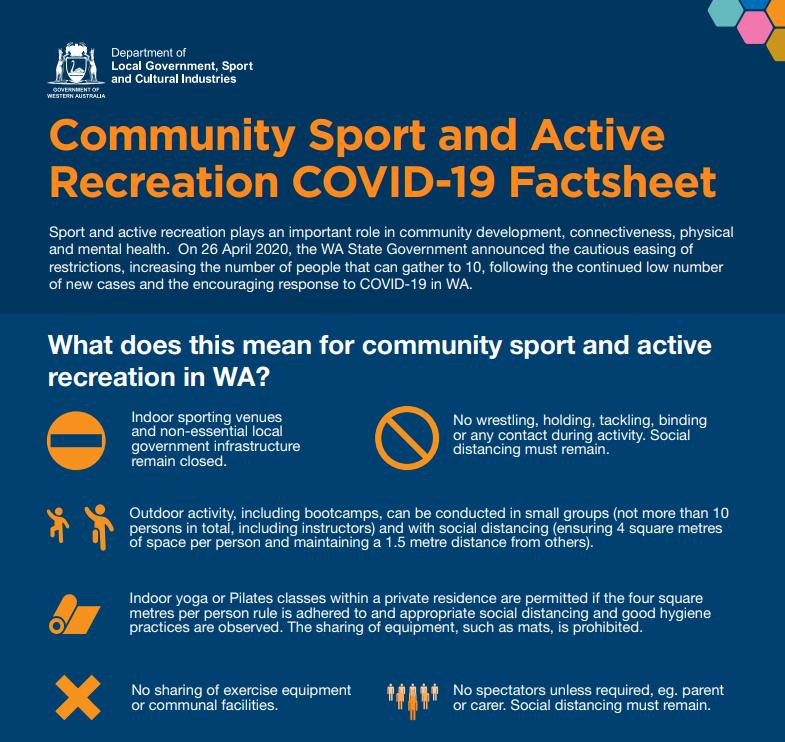Specify some key components in this picture. It is recommended to maintain a minimum of 4 square metres of personal space between individuals to aid in social distancing during a pandemic. 